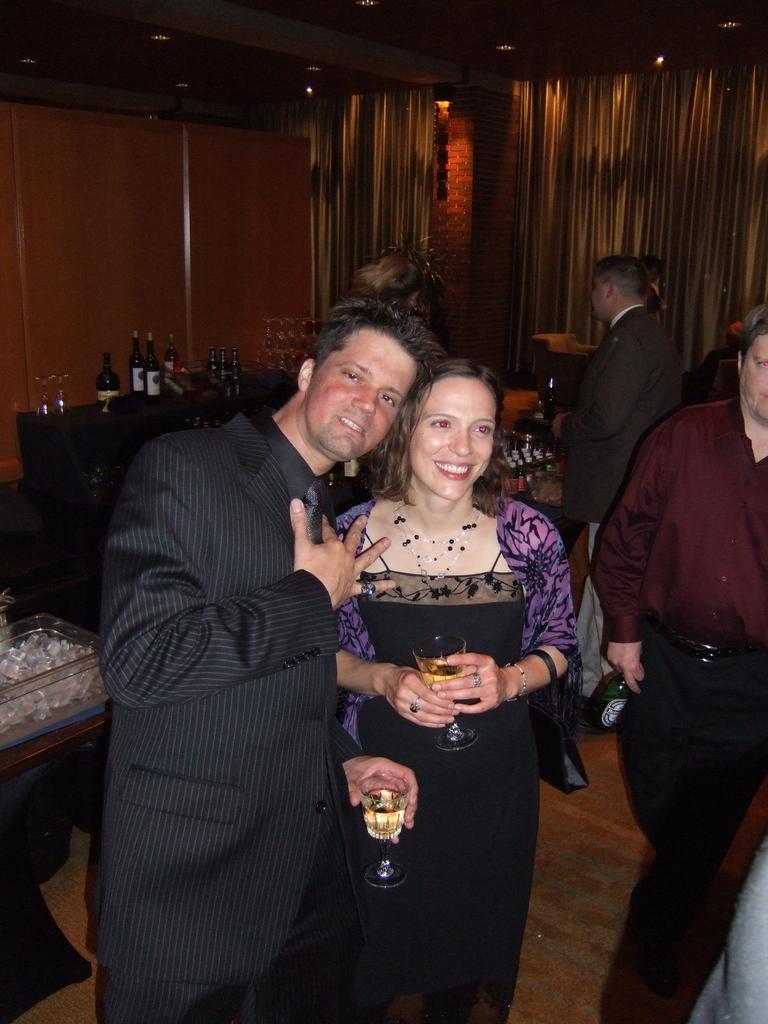How would you summarize this image in a sentence or two? In this image we can see this man and woman are holding a glass with a drink in it are standing on the floor and smiling. In the background, we can see a few more people, we can see the bottles and glasses are kept on the table, we can see the curtains and the wall. Here we can see a container with ice cubes placed on the table. 